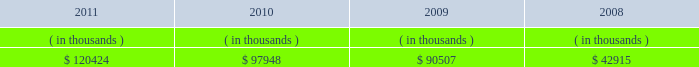System energy resources , inc .
Management 2019s financial discussion and analysis sources of capital system energy 2019s sources to meet its capital requirements include : internally generated funds ; cash on hand ; debt issuances ; and bank financing under new or existing facilities .
System energy may refinance , redeem , or otherwise retire debt prior to maturity , to the extent market conditions and interest and dividend rates are favorable .
All debt and common stock issuances by system energy require prior regulatory approval .
Debt issuances are also subject to issuance tests set forth in its bond indentures and other agreements .
System energy has sufficient capacity under these tests to meet its foreseeable capital needs .
In february 2012 , system energy vie issued $ 50 million of 4.02% ( 4.02 % ) series h notes due february 2017 .
System energy used the proceeds to purchase additional nuclear fuel .
System energy has obtained a short-term borrowing authorization from the ferc under which it may borrow , through october 2013 , up to the aggregate amount , at any one time outstanding , of $ 200 million .
See note 4 to the financial statements for further discussion of system energy 2019s short-term borrowing limits .
System energy has also obtained an order from the ferc authorizing long-term securities issuances .
The current long-term authorization extends through july 2013 .
System energy 2019s receivables from the money pool were as follows as of december 31 for each of the following years: .
See note 4 to the financial statements for a description of the money pool .
Nuclear matters system energy owns and operates grand gulf .
System energy is , therefore , subject to the risks related to owning and operating a nuclear plant .
These include risks from the use , storage , handling and disposal of high- level and low-level radioactive materials , regulatory requirement changes , including changes resulting from events at other plants , limitations on the amounts and types of insurance commercially available for losses in connection with nuclear operations , and technological and financial uncertainties related to decommissioning nuclear plants at the end of their licensed lives , including the sufficiency of funds in decommissioning trusts .
In the event of an unanticipated early shutdown of grand gulf , system energy may be required to provide additional funds or credit support to satisfy regulatory requirements for decommissioning .
After the nuclear incident in japan resulting from the march 2011 earthquake and tsunami , the nrc established a task force to conduct a review of processes and regulations relating to nuclear facilities in the united states .
The task force issued a near term ( 90-day ) report in july 2011 that has made recommendations , which are currently being evaluated by the nrc .
It is anticipated that the nrc will issue certain orders and requests for information to nuclear plant licensees by the end of the first quarter 2012 that will begin to implement the task force 2019s recommendations .
These orders may require u.s .
Nuclear operators , including entergy , to undertake plant modifications or perform additional analyses that could , among other things , result in increased costs and capital requirements associated with operating entergy 2019s nuclear plants. .
What was the average system energy 2019s receivables from 2008 to 2011? 
Computations: (((((120424 + 97948) + 90507) + 42915) + 4) / 2)
Answer: 175899.0. 